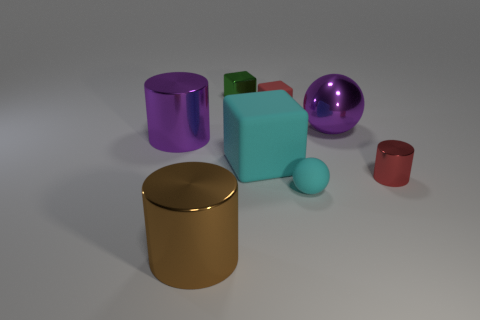How many objects are there, and can you tell their shapes? There are six distinct objects in the image. Starting from the left, we have a purple cylinder, a large gold cylinder with a reflective top, a small green cube, a cyan box with a lighter top, a shiny purple sphere, and a small red cup.  What can you infer about the material properties of these objects? Based on the way the light interacts with these objects, we can infer several material properties. The objects reflect light to varying degrees, suggesting differences in texture and sheen. The purple cylinder and gold cylinder appear highly reflective, likely simulating a metallic finish, while the green cube and red cup have a less reflective, possibly plastic-like surface. The purple sphere and the cyan box are also reflective, yet they appear to have a smoother finish, which could imply a glossy paint or polished surface. 